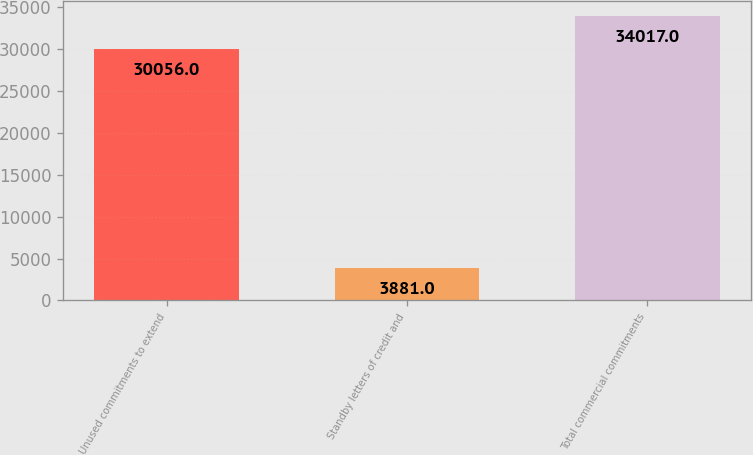Convert chart. <chart><loc_0><loc_0><loc_500><loc_500><bar_chart><fcel>Unused commitments to extend<fcel>Standby letters of credit and<fcel>Total commercial commitments<nl><fcel>30056<fcel>3881<fcel>34017<nl></chart> 